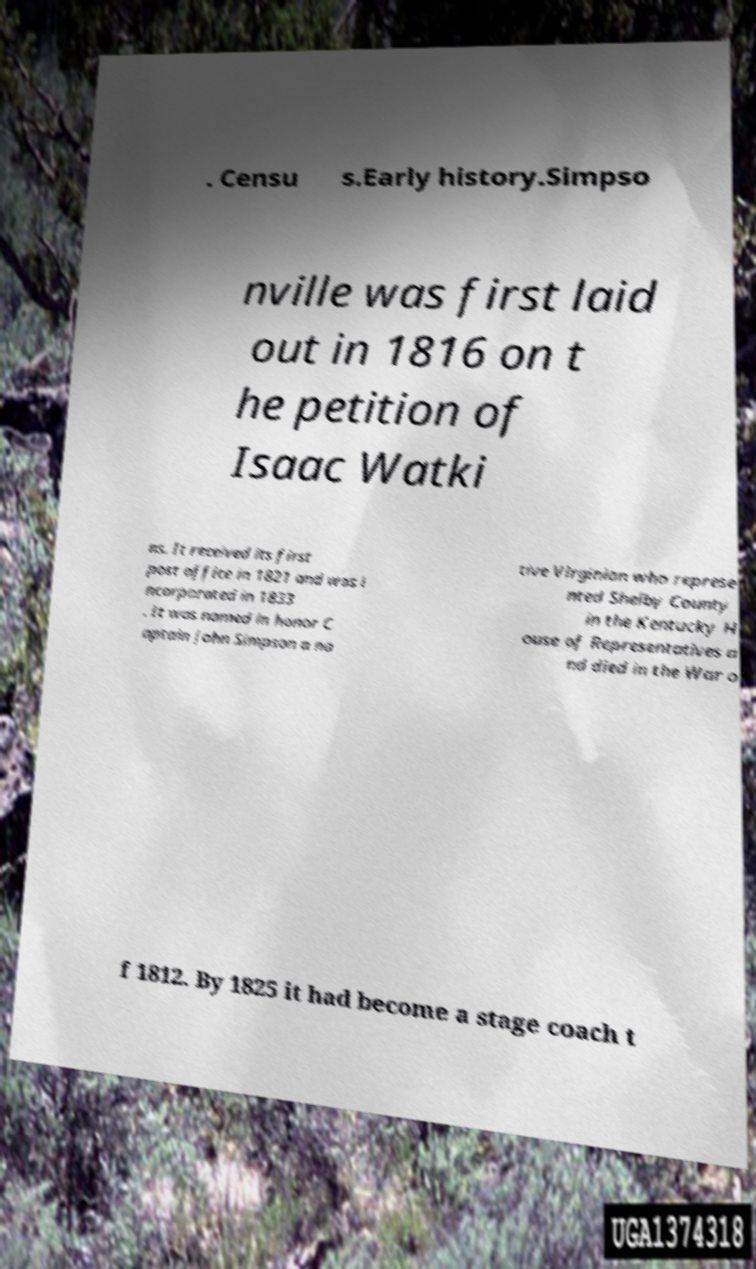I need the written content from this picture converted into text. Can you do that? . Censu s.Early history.Simpso nville was first laid out in 1816 on t he petition of Isaac Watki ns. It received its first post office in 1821 and was i ncorporated in 1833 . It was named in honor C aptain John Simpson a na tive Virginian who represe nted Shelby County in the Kentucky H ouse of Representatives a nd died in the War o f 1812. By 1825 it had become a stage coach t 